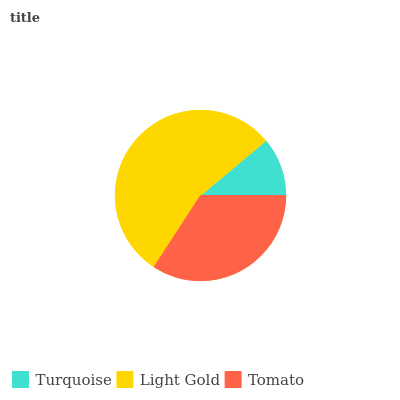Is Turquoise the minimum?
Answer yes or no. Yes. Is Light Gold the maximum?
Answer yes or no. Yes. Is Tomato the minimum?
Answer yes or no. No. Is Tomato the maximum?
Answer yes or no. No. Is Light Gold greater than Tomato?
Answer yes or no. Yes. Is Tomato less than Light Gold?
Answer yes or no. Yes. Is Tomato greater than Light Gold?
Answer yes or no. No. Is Light Gold less than Tomato?
Answer yes or no. No. Is Tomato the high median?
Answer yes or no. Yes. Is Tomato the low median?
Answer yes or no. Yes. Is Turquoise the high median?
Answer yes or no. No. Is Turquoise the low median?
Answer yes or no. No. 